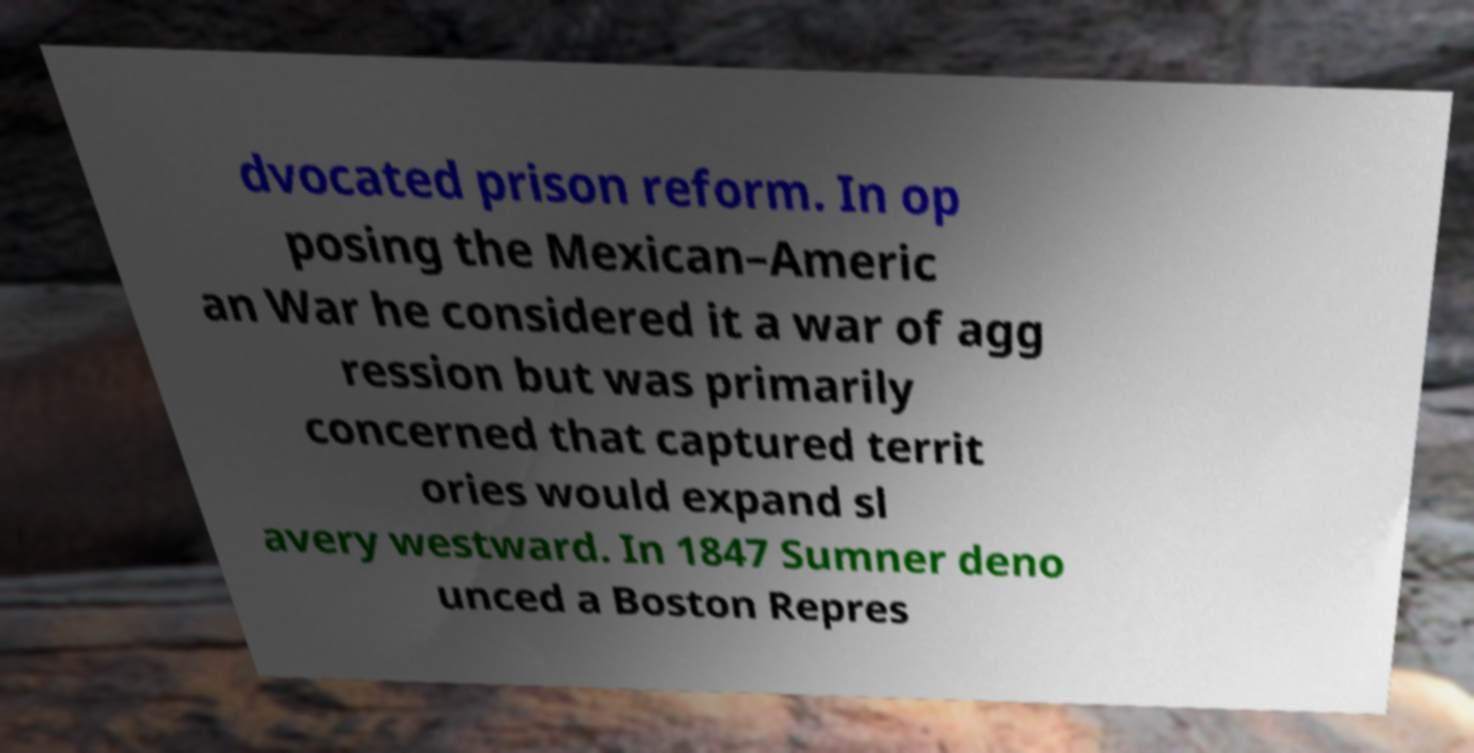I need the written content from this picture converted into text. Can you do that? dvocated prison reform. In op posing the Mexican–Americ an War he considered it a war of agg ression but was primarily concerned that captured territ ories would expand sl avery westward. In 1847 Sumner deno unced a Boston Repres 